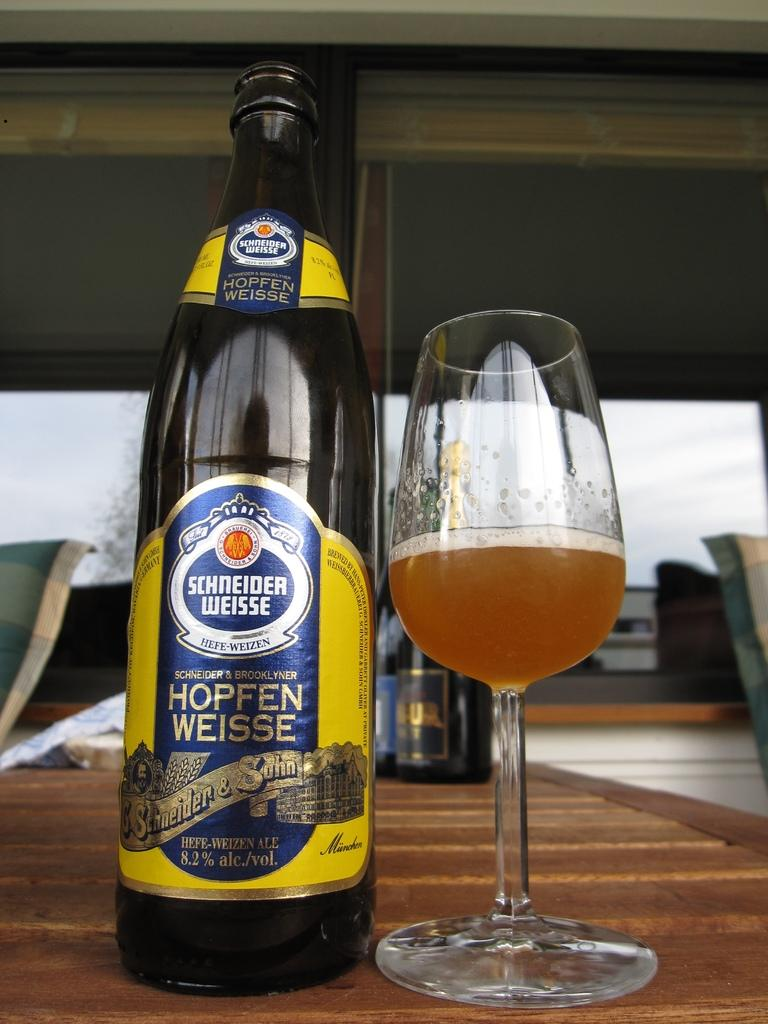<image>
Share a concise interpretation of the image provided. A bottle of Schneider Weisse Hopfen Weisse next to a half filled glass. 